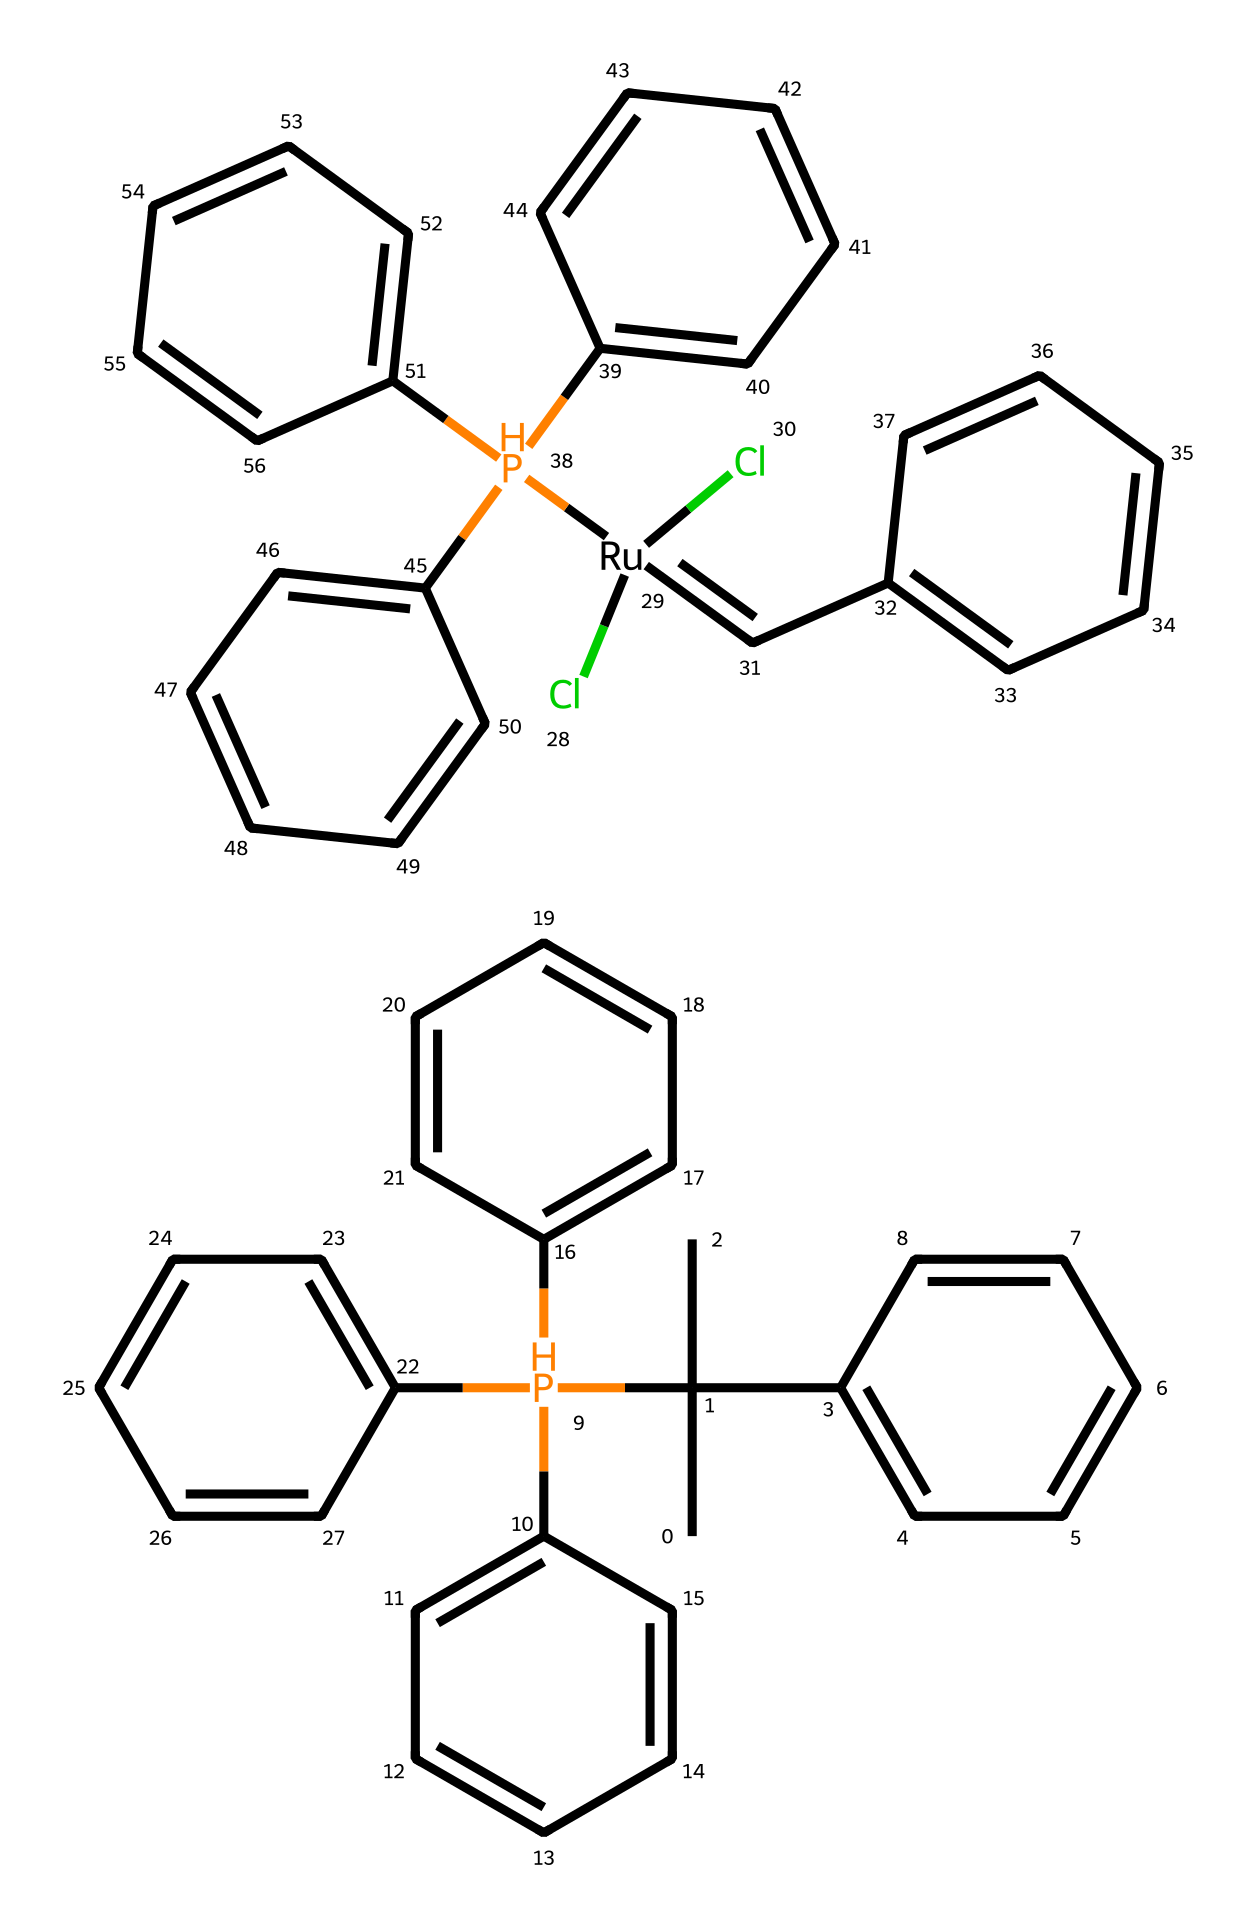What is the main metal center in this Grubbs catalyst? The main metal center in the chemical structure is represented by Ruthenium, as indicated by the symbol "[Ru]" in the SMILES representation.
Answer: Ruthenium How many phosphorus atoms are present in this molecule? By examining the SMILES structure, we can count the number of "P" symbols, which indicates the presence of phosphorus atoms. There are four phosphorus atoms present in the molecule.
Answer: 4 What type of reaction is this compound primarily used for? Grubbs catalyst is primarily used in olefin metathesis reactions, which is a type of reaction involving the exchange of alkene components. This is inherent to its application in organic chemistry.
Answer: olefin metathesis What is the total number of cyclohexane rings in this chemical structure? In the SMILES representation, the presence of multiple aromatic rings can be counted, with five instances of "C" followed by the structure indicating ring closure (i.e., equals). Thus, the total number of distinct cyclohexane rings is three.
Answer: 3 How many chlorine atoms are present in this organometallic compound? The count of chlorine atoms can be made by identifying the "Cl" symbols in the SMILES, where there are two "Cl" designations indicating the presence of chlorine atoms.
Answer: 2 What characteristic feature defines this complex as an organometallic? The defining feature that identifies this complex as an organometallic is the direct bonding between carbon (from the olefin) and a metal (Ruthenium), which is a hallmark of organometallic chemistry.
Answer: carbon-metal bond Which functional groups are primarily represented in this catalyst? The structure includes multiple phenyl (aromatic) rings and phosphine (due to the phosphorus atoms), which are the primary functional groups indicated in this organometallic compound.
Answer: phenyl and phosphine 